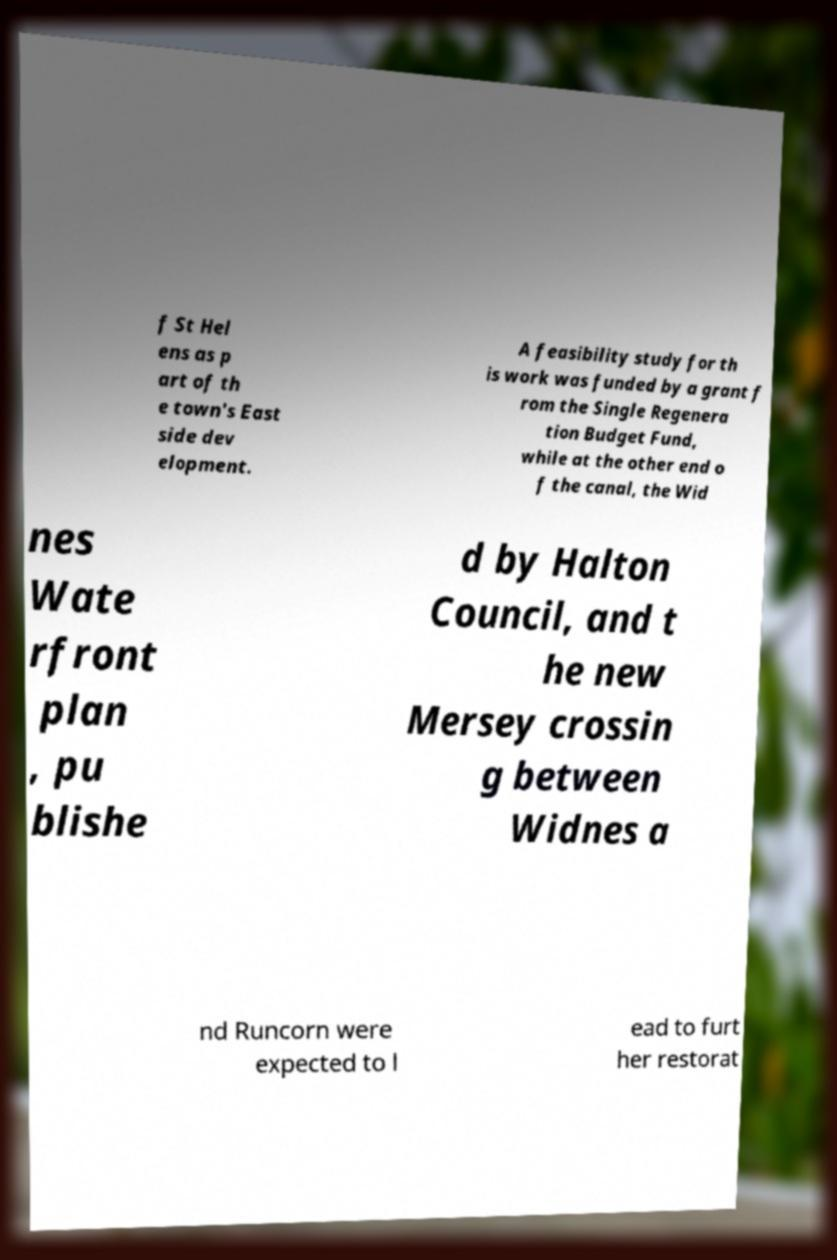Please read and relay the text visible in this image. What does it say? f St Hel ens as p art of th e town's East side dev elopment. A feasibility study for th is work was funded by a grant f rom the Single Regenera tion Budget Fund, while at the other end o f the canal, the Wid nes Wate rfront plan , pu blishe d by Halton Council, and t he new Mersey crossin g between Widnes a nd Runcorn were expected to l ead to furt her restorat 